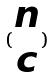<formula> <loc_0><loc_0><loc_500><loc_500>( \begin{matrix} n \\ c \end{matrix} )</formula> 